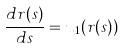<formula> <loc_0><loc_0><loc_500><loc_500>\frac { d r ( s ) } { d s } = u _ { 1 } ( r ( s ) )</formula> 